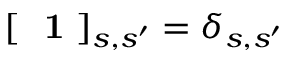<formula> <loc_0><loc_0><loc_500><loc_500>[ 1 ] _ { s , s ^ { \prime } } = \delta _ { s , s ^ { \prime } }</formula> 